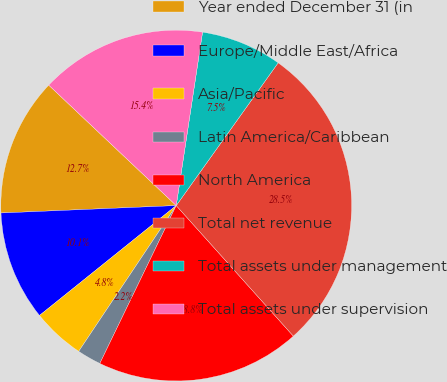Convert chart. <chart><loc_0><loc_0><loc_500><loc_500><pie_chart><fcel>Year ended December 31 (in<fcel>Europe/Middle East/Africa<fcel>Asia/Pacific<fcel>Latin America/Caribbean<fcel>North America<fcel>Total net revenue<fcel>Total assets under management<fcel>Total assets under supervision<nl><fcel>12.72%<fcel>10.1%<fcel>4.84%<fcel>2.21%<fcel>18.81%<fcel>28.49%<fcel>7.47%<fcel>15.35%<nl></chart> 